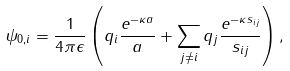Convert formula to latex. <formula><loc_0><loc_0><loc_500><loc_500>\psi _ { 0 , i } = \frac { 1 } { 4 \pi \epsilon } \left ( q _ { i } \frac { e ^ { - \kappa a } } { a } + \sum _ { j \ne i } q _ { j } \frac { e ^ { - \kappa s _ { i j } } } { s _ { i j } } \right ) ,</formula> 